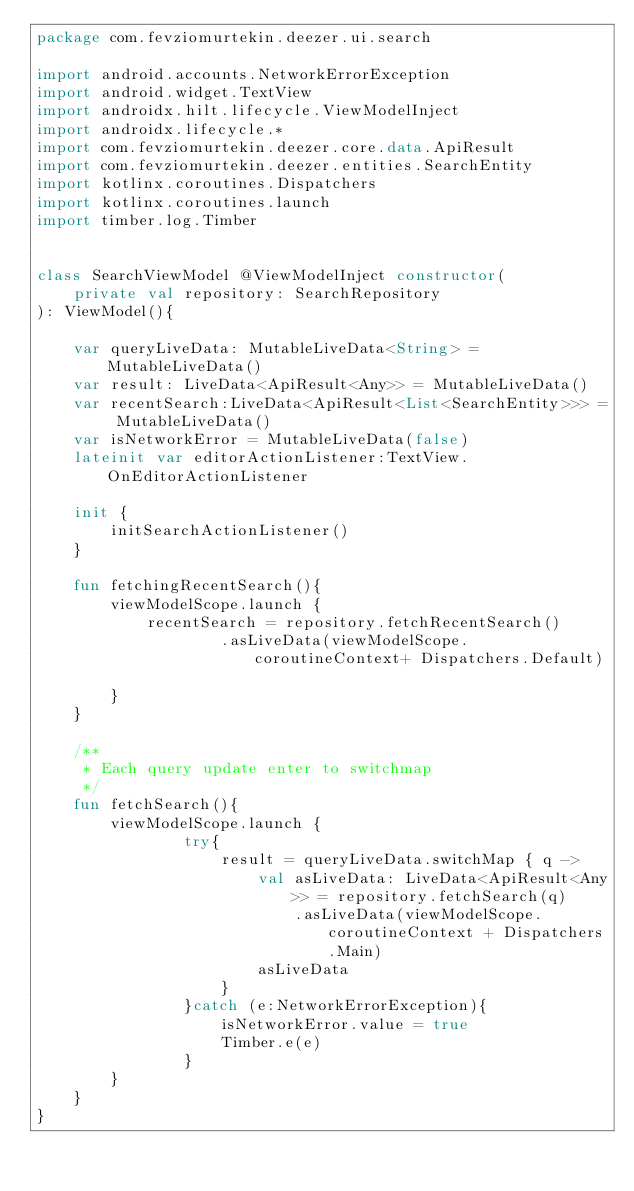<code> <loc_0><loc_0><loc_500><loc_500><_Kotlin_>package com.fevziomurtekin.deezer.ui.search

import android.accounts.NetworkErrorException
import android.widget.TextView
import androidx.hilt.lifecycle.ViewModelInject
import androidx.lifecycle.*
import com.fevziomurtekin.deezer.core.data.ApiResult
import com.fevziomurtekin.deezer.entities.SearchEntity
import kotlinx.coroutines.Dispatchers
import kotlinx.coroutines.launch
import timber.log.Timber


class SearchViewModel @ViewModelInject constructor(
    private val repository: SearchRepository
): ViewModel(){

    var queryLiveData: MutableLiveData<String> = MutableLiveData()
    var result: LiveData<ApiResult<Any>> = MutableLiveData()
    var recentSearch:LiveData<ApiResult<List<SearchEntity>>> = MutableLiveData()
    var isNetworkError = MutableLiveData(false)
    lateinit var editorActionListener:TextView.OnEditorActionListener

    init {
        initSearchActionListener()
    }

    fun fetchingRecentSearch(){
        viewModelScope.launch {
            recentSearch = repository.fetchRecentSearch()
                    .asLiveData(viewModelScope.coroutineContext+ Dispatchers.Default)

        }
    }

    /**
     * Each query update enter to switchmap
     */
    fun fetchSearch(){
        viewModelScope.launch {
                try{
                    result = queryLiveData.switchMap { q ->
                        val asLiveData: LiveData<ApiResult<Any>> = repository.fetchSearch(q)
                            .asLiveData(viewModelScope.coroutineContext + Dispatchers.Main)
                        asLiveData
                    }
                }catch (e:NetworkErrorException){
                    isNetworkError.value = true
                    Timber.e(e)
                }
        }
    }
}
</code> 